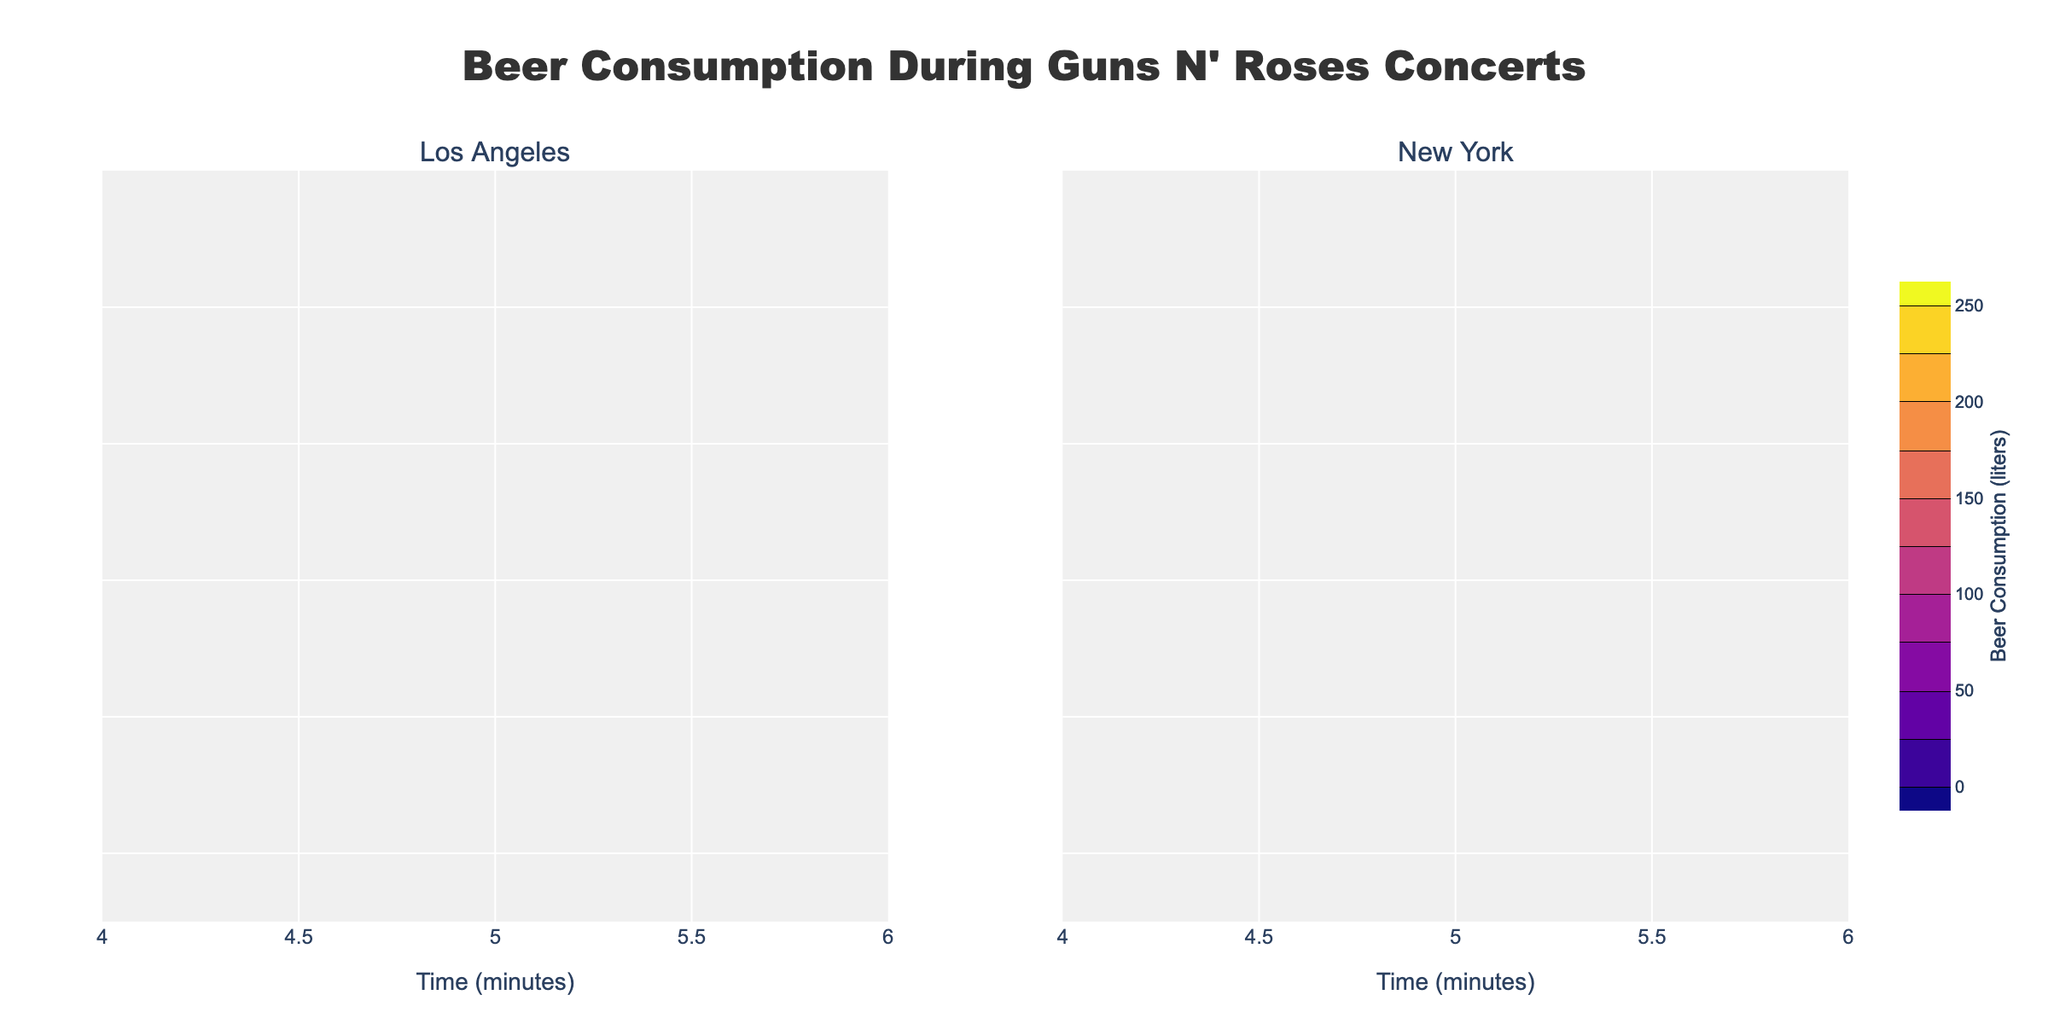What is the title of the plot? The title is usually found at the top of the figure and provides a concise description of what the plot represents. In this case, it is located centrally at the top.
Answer: Beer Consumption During Guns N' Roses Concerts How many subplots are shown in the figure? The entire plot is divided into sections, each representing a different scenario or location. Here, each location has its own subplot. There are two subplots.
Answer: Two Which location shows higher beer consumption at the 20-minute mark? Look at the 20-minute mark on both subplots, and compare the beer consumption values found on the contours. In Los Angeles at 20 minutes, the consumption is 150 liters, while in New York, it is 140 liters.
Answer: Los Angeles At what time interval is the peak beer consumption reached in Los Angeles? Find the highest contour label within the Los Angeles subplot and identify the corresponding time value. The peak beer consumption is 250 liters at the 30-minute mark.
Answer: 30 minutes Is there a significant drop in beer consumption after the peak in both locations? Compare the highest consumption point in both cities to the subsequent values. Both subplots show a peak (250 liters for Los Angeles and New York at 30 minutes) followed by a downward trend, indicating a significant drop.
Answer: Yes What is the color scale used for Los Angeles? Each subplot is associated with a specific color scale. In Los Angeles, the color scale is identified at the legend bar to the right of the subplot. Los Angeles uses the Viridis color scale.
Answer: Viridis Compare the beer consumption patterns between Los Angeles and New York. Compare the general trends and values of beer consumption over time in both subplots. Both locations show an increasing trend reaching a peak at 30 minutes, followed by a decline. The patterns look similar with slight variations in values close to the peak and post-peak consumption.
Answer: Similar patterns with variations near the peak At 50 minutes, how much beer consumption differs between the two locations? Locate the 50-minute mark on both subplots and read the consumption values. In Los Angeles, it is 120 liters, and in New York, it is 110 liters. The difference is 120 - 110.
Answer: 10 liters What is the font family used in the plot's title? The font family can often be identified from the style settings or observation. In this plot, it is mentioned that the font family for the title is 'Arial Black'.
Answer: Arial Black 